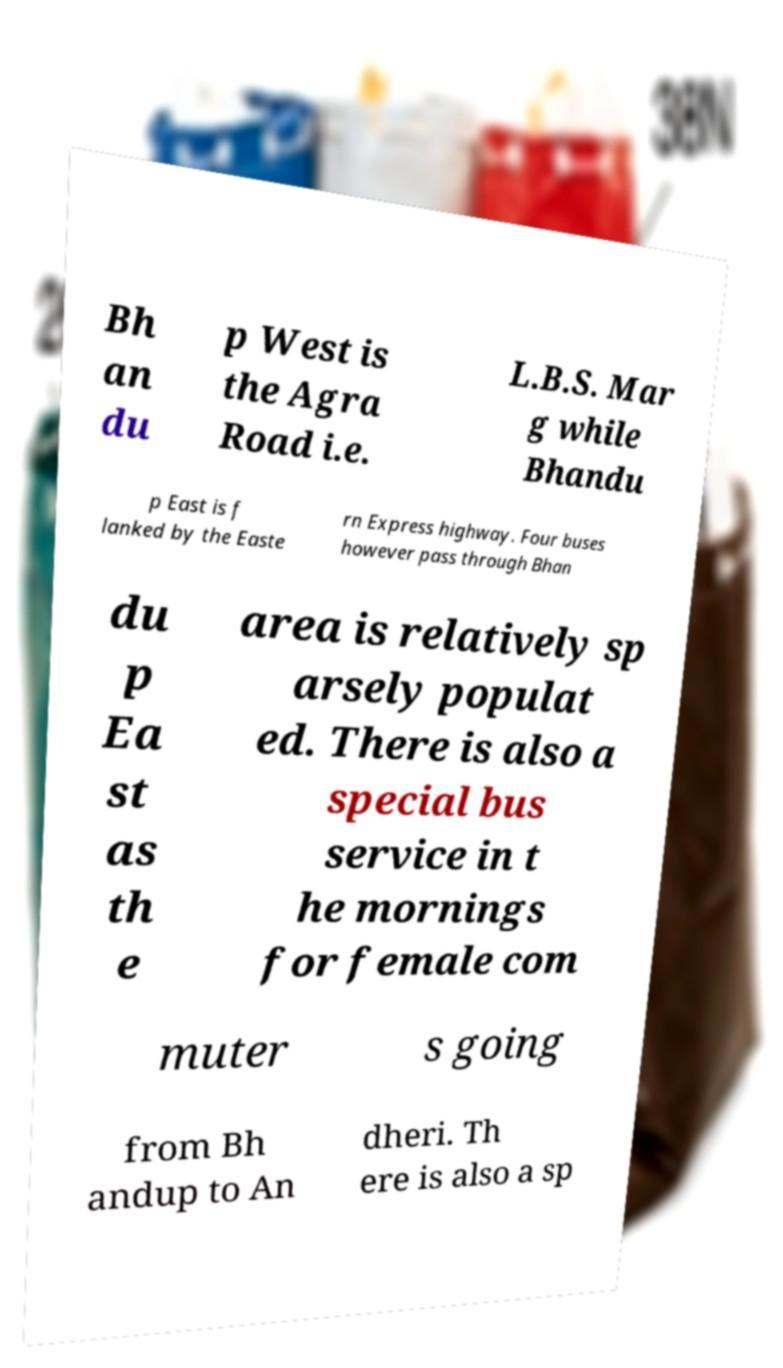Please identify and transcribe the text found in this image. Bh an du p West is the Agra Road i.e. L.B.S. Mar g while Bhandu p East is f lanked by the Easte rn Express highway. Four buses however pass through Bhan du p Ea st as th e area is relatively sp arsely populat ed. There is also a special bus service in t he mornings for female com muter s going from Bh andup to An dheri. Th ere is also a sp 